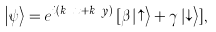Convert formula to latex. <formula><loc_0><loc_0><loc_500><loc_500>\left | \psi \right > = e ^ { i ( k _ { x } x + k _ { y } y ) } \, [ \beta \left | \uparrow \right > + \gamma \left | \downarrow \right > ] ,</formula> 